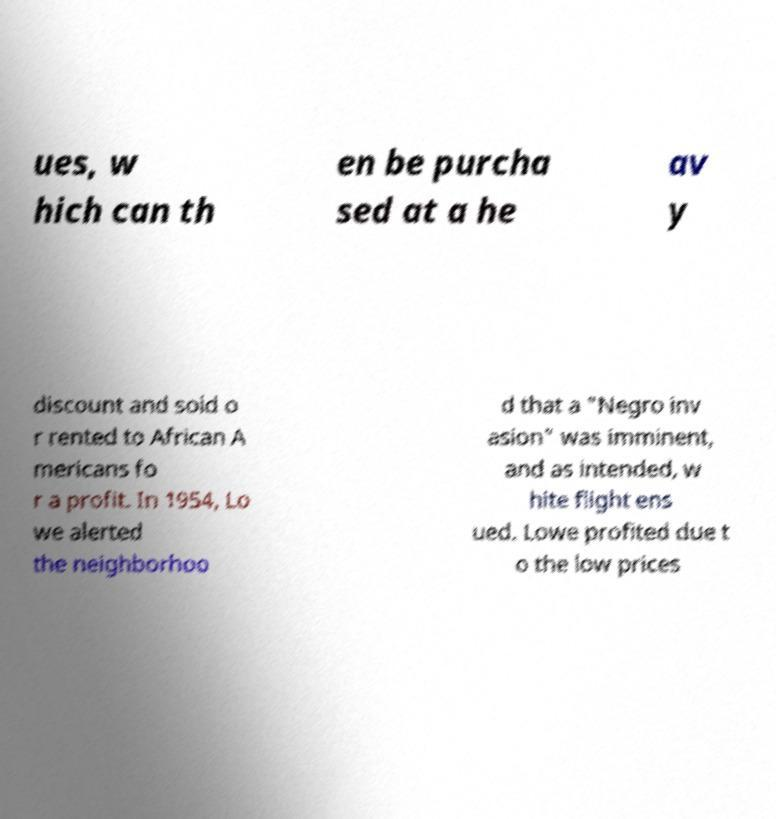For documentation purposes, I need the text within this image transcribed. Could you provide that? ues, w hich can th en be purcha sed at a he av y discount and sold o r rented to African A mericans fo r a profit. In 1954, Lo we alerted the neighborhoo d that a "Negro inv asion" was imminent, and as intended, w hite flight ens ued. Lowe profited due t o the low prices 